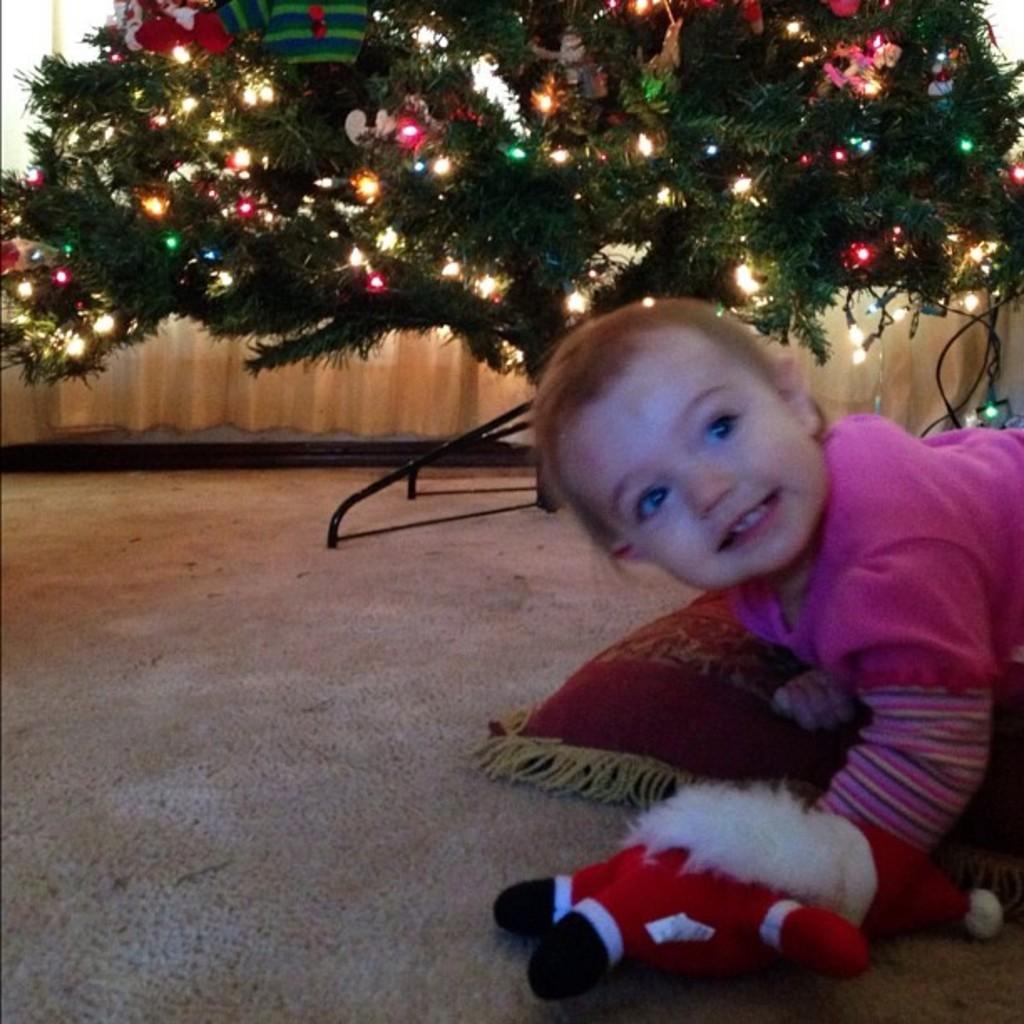Describe this image in one or two sentences. In this picture we can see a baby, pillow, doll on the floor and in the background we can see a tree with lights, toys on it, stand, curtains. 